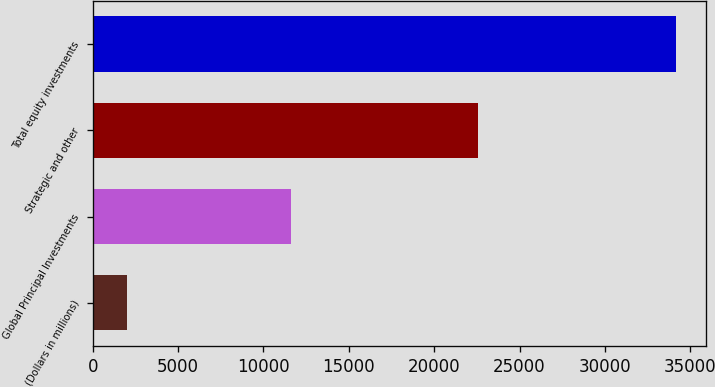Convert chart to OTSL. <chart><loc_0><loc_0><loc_500><loc_500><bar_chart><fcel>(Dollars in millions)<fcel>Global Principal Investments<fcel>Strategic and other<fcel>Total equity investments<nl><fcel>2010<fcel>11640<fcel>22545<fcel>34185<nl></chart> 